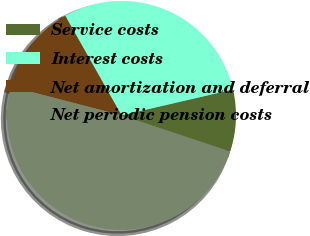Convert chart. <chart><loc_0><loc_0><loc_500><loc_500><pie_chart><fcel>Service costs<fcel>Interest costs<fcel>Net amortization and deferral<fcel>Net periodic pension costs<nl><fcel>8.75%<fcel>29.57%<fcel>12.76%<fcel>48.92%<nl></chart> 